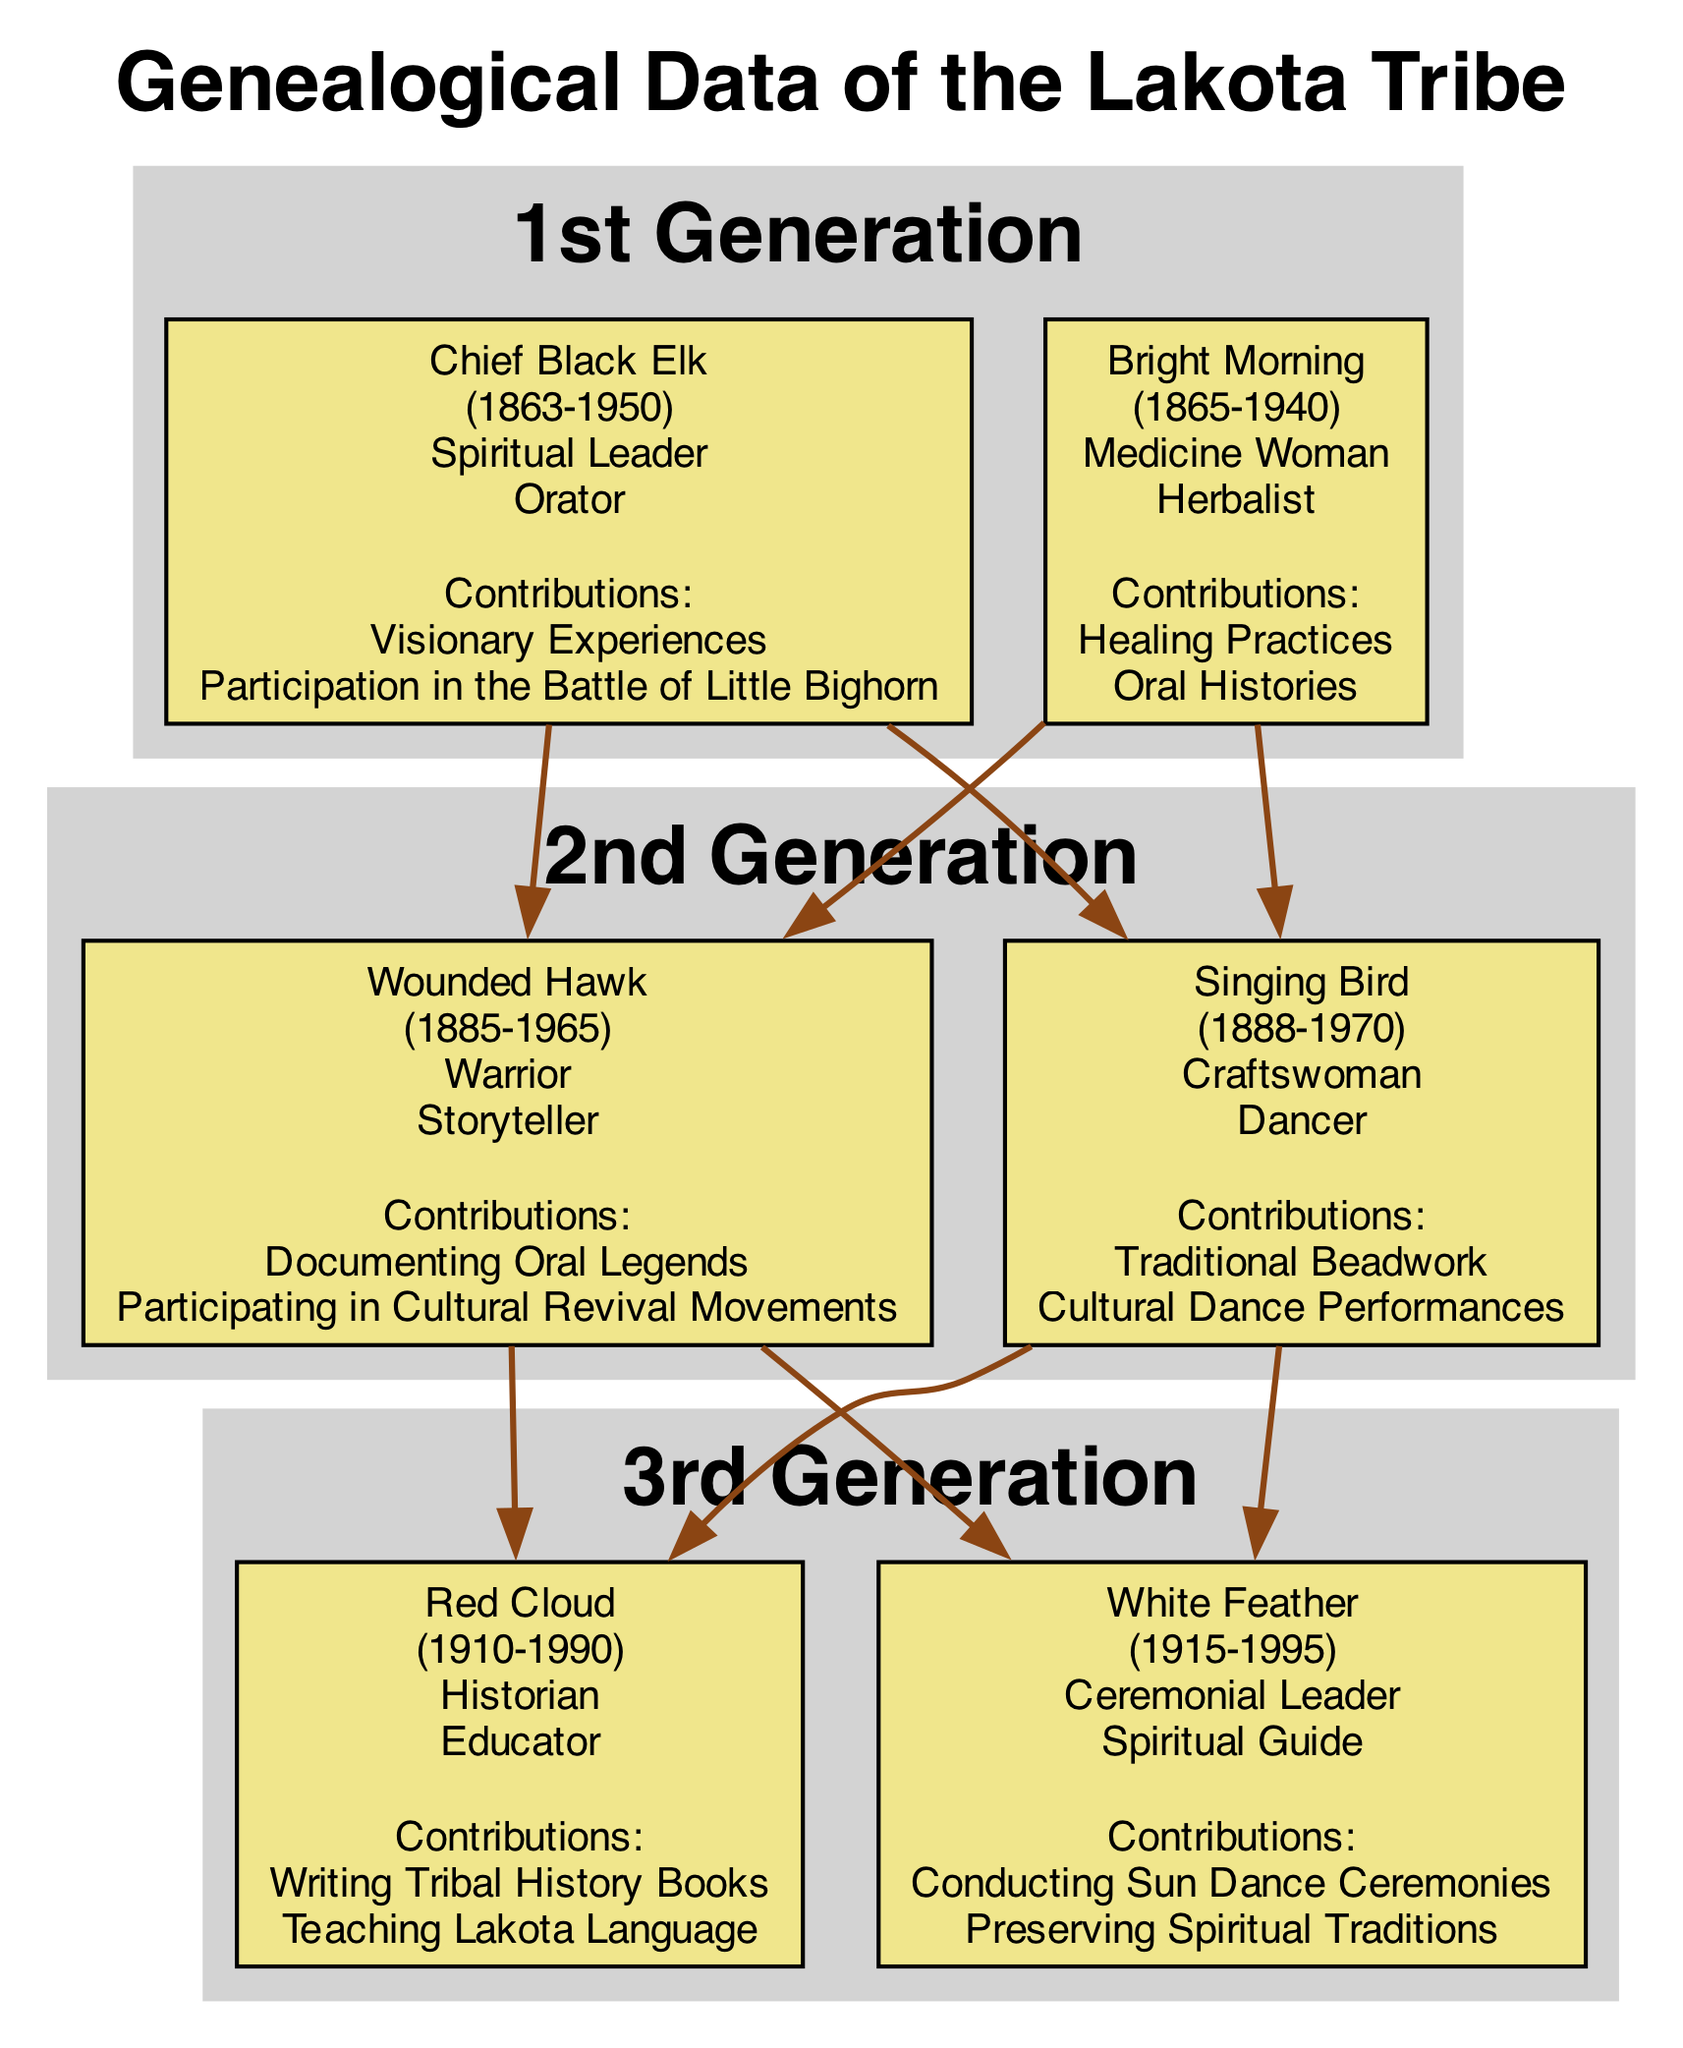What is the birth year of Chief Black Elk? The diagram lists the birth year of Chief Black Elk as 1863. This information is typically found in the member details section of the diagram.
Answer: 1863 Who are the parents of Wounded Hawk? According to the diagram, Wounded Hawk's parents are Chief Black Elk and Bright Morning. This relationship is indicated in the family tree by lines connecting Wounded Hawk to his parents.
Answer: Chief Black Elk, Bright Morning How many generations are represented in the diagram? The diagram shows three distinct generations labeled as 1st Generation, 2nd Generation, and 3rd Generation. Each generation clearly lists its members, indicating a total of three generations in the family tree.
Answer: 3 Which cultural trait is associated with Singing Bird? The diagram indicates two cultural traits associated with Singing Bird: Craftswoman and Dancer. This information is included under Singing Bird's member details, which lists cultural traits in a dedicated section.
Answer: Craftswoman, Dancer What significant contributions did Red Cloud make? Red Cloud is noted for two contributions: Writing Tribal History Books and Teaching Lakota Language. These are listed under his contributions section within the member details of the diagram.
Answer: Writing Tribal History Books, Teaching Lakota Language Which member contributed to Healing Practices? The diagram shows that Bright Morning contributed to Healing Practices. This information is part of her contributions listed under her member details.
Answer: Bright Morning In which year did White Feather pass away? The diagram indicates that White Feather passed away in 1995. This information is reflected in his member details that include the death year.
Answer: 1995 What is the cultural trait of Chief Black Elk that signifies his role in the community? The cultural trait Spiritual Leader signifies Chief Black Elk's role in the community. This trait is listed under his member details, emphasizing his important position.
Answer: Spiritual Leader Who is the ceremonial leader in the 3rd Generation? The diagram identifies White Feather as the ceremonial leader in the 3rd Generation. This detail is part of his cultural traits listed under his member information.
Answer: White Feather 